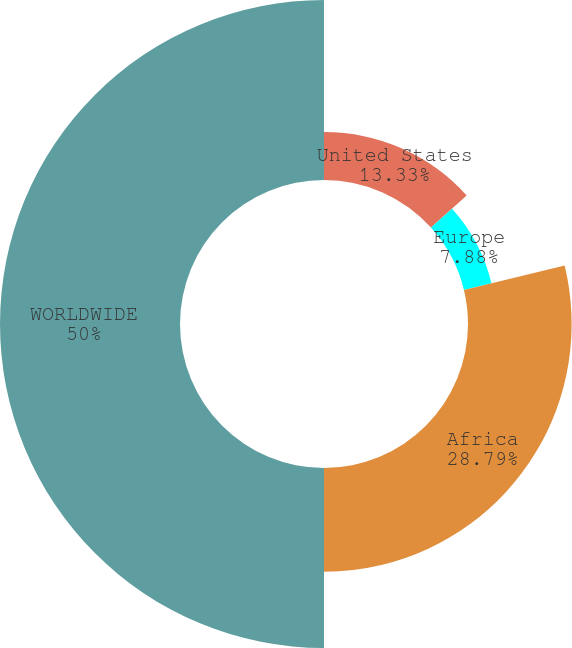Convert chart to OTSL. <chart><loc_0><loc_0><loc_500><loc_500><pie_chart><fcel>United States<fcel>Europe<fcel>Africa<fcel>WORLDWIDE<nl><fcel>13.33%<fcel>7.88%<fcel>28.79%<fcel>50.0%<nl></chart> 